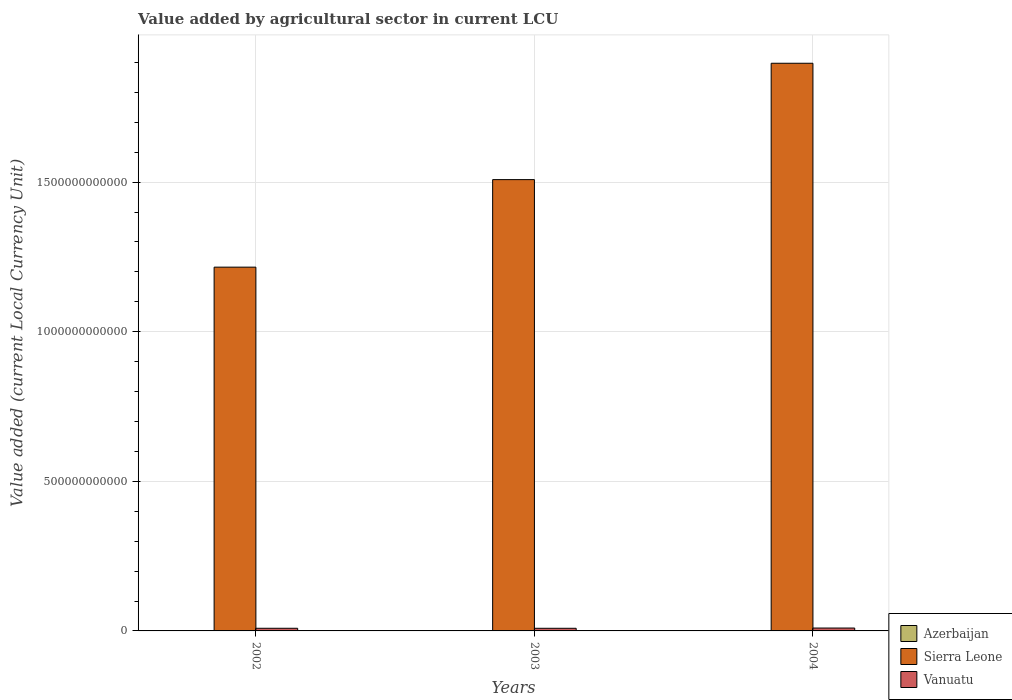How many different coloured bars are there?
Give a very brief answer. 3. Are the number of bars per tick equal to the number of legend labels?
Provide a succinct answer. Yes. Are the number of bars on each tick of the X-axis equal?
Your response must be concise. Yes. How many bars are there on the 1st tick from the right?
Keep it short and to the point. 3. In how many cases, is the number of bars for a given year not equal to the number of legend labels?
Give a very brief answer. 0. What is the value added by agricultural sector in Azerbaijan in 2003?
Provide a succinct answer. 8.88e+08. Across all years, what is the maximum value added by agricultural sector in Azerbaijan?
Make the answer very short. 9.37e+08. Across all years, what is the minimum value added by agricultural sector in Sierra Leone?
Your answer should be compact. 1.22e+12. In which year was the value added by agricultural sector in Azerbaijan minimum?
Give a very brief answer. 2002. What is the total value added by agricultural sector in Vanuatu in the graph?
Your response must be concise. 2.73e+1. What is the difference between the value added by agricultural sector in Vanuatu in 2002 and that in 2003?
Give a very brief answer. 9.80e+07. What is the difference between the value added by agricultural sector in Azerbaijan in 2003 and the value added by agricultural sector in Sierra Leone in 2002?
Offer a very short reply. -1.21e+12. What is the average value added by agricultural sector in Vanuatu per year?
Make the answer very short. 9.09e+09. In the year 2003, what is the difference between the value added by agricultural sector in Vanuatu and value added by agricultural sector in Sierra Leone?
Offer a terse response. -1.50e+12. What is the ratio of the value added by agricultural sector in Sierra Leone in 2003 to that in 2004?
Offer a very short reply. 0.8. Is the value added by agricultural sector in Vanuatu in 2002 less than that in 2004?
Provide a short and direct response. Yes. What is the difference between the highest and the second highest value added by agricultural sector in Vanuatu?
Give a very brief answer. 7.59e+08. What is the difference between the highest and the lowest value added by agricultural sector in Sierra Leone?
Provide a short and direct response. 6.81e+11. In how many years, is the value added by agricultural sector in Azerbaijan greater than the average value added by agricultural sector in Azerbaijan taken over all years?
Offer a terse response. 1. What does the 1st bar from the left in 2003 represents?
Your answer should be very brief. Azerbaijan. What does the 3rd bar from the right in 2004 represents?
Offer a very short reply. Azerbaijan. Is it the case that in every year, the sum of the value added by agricultural sector in Sierra Leone and value added by agricultural sector in Vanuatu is greater than the value added by agricultural sector in Azerbaijan?
Offer a very short reply. Yes. How many years are there in the graph?
Provide a succinct answer. 3. What is the difference between two consecutive major ticks on the Y-axis?
Your answer should be very brief. 5.00e+11. How many legend labels are there?
Offer a terse response. 3. How are the legend labels stacked?
Offer a terse response. Vertical. What is the title of the graph?
Keep it short and to the point. Value added by agricultural sector in current LCU. What is the label or title of the Y-axis?
Offer a very short reply. Value added (current Local Currency Unit). What is the Value added (current Local Currency Unit) in Azerbaijan in 2002?
Provide a short and direct response. 8.46e+08. What is the Value added (current Local Currency Unit) in Sierra Leone in 2002?
Keep it short and to the point. 1.22e+12. What is the Value added (current Local Currency Unit) of Vanuatu in 2002?
Offer a terse response. 8.87e+09. What is the Value added (current Local Currency Unit) in Azerbaijan in 2003?
Provide a succinct answer. 8.88e+08. What is the Value added (current Local Currency Unit) of Sierra Leone in 2003?
Your response must be concise. 1.51e+12. What is the Value added (current Local Currency Unit) in Vanuatu in 2003?
Provide a succinct answer. 8.77e+09. What is the Value added (current Local Currency Unit) of Azerbaijan in 2004?
Ensure brevity in your answer.  9.37e+08. What is the Value added (current Local Currency Unit) of Sierra Leone in 2004?
Provide a succinct answer. 1.90e+12. What is the Value added (current Local Currency Unit) in Vanuatu in 2004?
Offer a very short reply. 9.63e+09. Across all years, what is the maximum Value added (current Local Currency Unit) of Azerbaijan?
Ensure brevity in your answer.  9.37e+08. Across all years, what is the maximum Value added (current Local Currency Unit) in Sierra Leone?
Provide a succinct answer. 1.90e+12. Across all years, what is the maximum Value added (current Local Currency Unit) of Vanuatu?
Your answer should be very brief. 9.63e+09. Across all years, what is the minimum Value added (current Local Currency Unit) in Azerbaijan?
Offer a very short reply. 8.46e+08. Across all years, what is the minimum Value added (current Local Currency Unit) in Sierra Leone?
Keep it short and to the point. 1.22e+12. Across all years, what is the minimum Value added (current Local Currency Unit) of Vanuatu?
Give a very brief answer. 8.77e+09. What is the total Value added (current Local Currency Unit) of Azerbaijan in the graph?
Your response must be concise. 2.67e+09. What is the total Value added (current Local Currency Unit) in Sierra Leone in the graph?
Your answer should be very brief. 4.62e+12. What is the total Value added (current Local Currency Unit) of Vanuatu in the graph?
Offer a very short reply. 2.73e+1. What is the difference between the Value added (current Local Currency Unit) in Azerbaijan in 2002 and that in 2003?
Your answer should be very brief. -4.20e+07. What is the difference between the Value added (current Local Currency Unit) in Sierra Leone in 2002 and that in 2003?
Provide a short and direct response. -2.93e+11. What is the difference between the Value added (current Local Currency Unit) of Vanuatu in 2002 and that in 2003?
Your answer should be compact. 9.80e+07. What is the difference between the Value added (current Local Currency Unit) of Azerbaijan in 2002 and that in 2004?
Provide a short and direct response. -9.13e+07. What is the difference between the Value added (current Local Currency Unit) of Sierra Leone in 2002 and that in 2004?
Ensure brevity in your answer.  -6.81e+11. What is the difference between the Value added (current Local Currency Unit) of Vanuatu in 2002 and that in 2004?
Ensure brevity in your answer.  -7.59e+08. What is the difference between the Value added (current Local Currency Unit) in Azerbaijan in 2003 and that in 2004?
Make the answer very short. -4.93e+07. What is the difference between the Value added (current Local Currency Unit) in Sierra Leone in 2003 and that in 2004?
Your response must be concise. -3.89e+11. What is the difference between the Value added (current Local Currency Unit) of Vanuatu in 2003 and that in 2004?
Your answer should be very brief. -8.57e+08. What is the difference between the Value added (current Local Currency Unit) of Azerbaijan in 2002 and the Value added (current Local Currency Unit) of Sierra Leone in 2003?
Provide a succinct answer. -1.51e+12. What is the difference between the Value added (current Local Currency Unit) in Azerbaijan in 2002 and the Value added (current Local Currency Unit) in Vanuatu in 2003?
Keep it short and to the point. -7.93e+09. What is the difference between the Value added (current Local Currency Unit) of Sierra Leone in 2002 and the Value added (current Local Currency Unit) of Vanuatu in 2003?
Keep it short and to the point. 1.21e+12. What is the difference between the Value added (current Local Currency Unit) of Azerbaijan in 2002 and the Value added (current Local Currency Unit) of Sierra Leone in 2004?
Offer a terse response. -1.90e+12. What is the difference between the Value added (current Local Currency Unit) of Azerbaijan in 2002 and the Value added (current Local Currency Unit) of Vanuatu in 2004?
Provide a short and direct response. -8.78e+09. What is the difference between the Value added (current Local Currency Unit) in Sierra Leone in 2002 and the Value added (current Local Currency Unit) in Vanuatu in 2004?
Your answer should be compact. 1.21e+12. What is the difference between the Value added (current Local Currency Unit) of Azerbaijan in 2003 and the Value added (current Local Currency Unit) of Sierra Leone in 2004?
Your answer should be very brief. -1.90e+12. What is the difference between the Value added (current Local Currency Unit) of Azerbaijan in 2003 and the Value added (current Local Currency Unit) of Vanuatu in 2004?
Your answer should be very brief. -8.74e+09. What is the difference between the Value added (current Local Currency Unit) in Sierra Leone in 2003 and the Value added (current Local Currency Unit) in Vanuatu in 2004?
Keep it short and to the point. 1.50e+12. What is the average Value added (current Local Currency Unit) in Azerbaijan per year?
Ensure brevity in your answer.  8.90e+08. What is the average Value added (current Local Currency Unit) of Sierra Leone per year?
Provide a succinct answer. 1.54e+12. What is the average Value added (current Local Currency Unit) of Vanuatu per year?
Offer a very short reply. 9.09e+09. In the year 2002, what is the difference between the Value added (current Local Currency Unit) in Azerbaijan and Value added (current Local Currency Unit) in Sierra Leone?
Ensure brevity in your answer.  -1.21e+12. In the year 2002, what is the difference between the Value added (current Local Currency Unit) of Azerbaijan and Value added (current Local Currency Unit) of Vanuatu?
Keep it short and to the point. -8.02e+09. In the year 2002, what is the difference between the Value added (current Local Currency Unit) in Sierra Leone and Value added (current Local Currency Unit) in Vanuatu?
Your answer should be compact. 1.21e+12. In the year 2003, what is the difference between the Value added (current Local Currency Unit) in Azerbaijan and Value added (current Local Currency Unit) in Sierra Leone?
Ensure brevity in your answer.  -1.51e+12. In the year 2003, what is the difference between the Value added (current Local Currency Unit) of Azerbaijan and Value added (current Local Currency Unit) of Vanuatu?
Make the answer very short. -7.88e+09. In the year 2003, what is the difference between the Value added (current Local Currency Unit) of Sierra Leone and Value added (current Local Currency Unit) of Vanuatu?
Offer a very short reply. 1.50e+12. In the year 2004, what is the difference between the Value added (current Local Currency Unit) of Azerbaijan and Value added (current Local Currency Unit) of Sierra Leone?
Your answer should be compact. -1.90e+12. In the year 2004, what is the difference between the Value added (current Local Currency Unit) in Azerbaijan and Value added (current Local Currency Unit) in Vanuatu?
Make the answer very short. -8.69e+09. In the year 2004, what is the difference between the Value added (current Local Currency Unit) in Sierra Leone and Value added (current Local Currency Unit) in Vanuatu?
Make the answer very short. 1.89e+12. What is the ratio of the Value added (current Local Currency Unit) in Azerbaijan in 2002 to that in 2003?
Your answer should be compact. 0.95. What is the ratio of the Value added (current Local Currency Unit) of Sierra Leone in 2002 to that in 2003?
Your response must be concise. 0.81. What is the ratio of the Value added (current Local Currency Unit) in Vanuatu in 2002 to that in 2003?
Your answer should be compact. 1.01. What is the ratio of the Value added (current Local Currency Unit) of Azerbaijan in 2002 to that in 2004?
Provide a succinct answer. 0.9. What is the ratio of the Value added (current Local Currency Unit) in Sierra Leone in 2002 to that in 2004?
Give a very brief answer. 0.64. What is the ratio of the Value added (current Local Currency Unit) of Vanuatu in 2002 to that in 2004?
Provide a succinct answer. 0.92. What is the ratio of the Value added (current Local Currency Unit) of Sierra Leone in 2003 to that in 2004?
Keep it short and to the point. 0.8. What is the ratio of the Value added (current Local Currency Unit) in Vanuatu in 2003 to that in 2004?
Offer a very short reply. 0.91. What is the difference between the highest and the second highest Value added (current Local Currency Unit) in Azerbaijan?
Keep it short and to the point. 4.93e+07. What is the difference between the highest and the second highest Value added (current Local Currency Unit) of Sierra Leone?
Your response must be concise. 3.89e+11. What is the difference between the highest and the second highest Value added (current Local Currency Unit) of Vanuatu?
Provide a succinct answer. 7.59e+08. What is the difference between the highest and the lowest Value added (current Local Currency Unit) in Azerbaijan?
Offer a very short reply. 9.13e+07. What is the difference between the highest and the lowest Value added (current Local Currency Unit) in Sierra Leone?
Give a very brief answer. 6.81e+11. What is the difference between the highest and the lowest Value added (current Local Currency Unit) in Vanuatu?
Provide a succinct answer. 8.57e+08. 